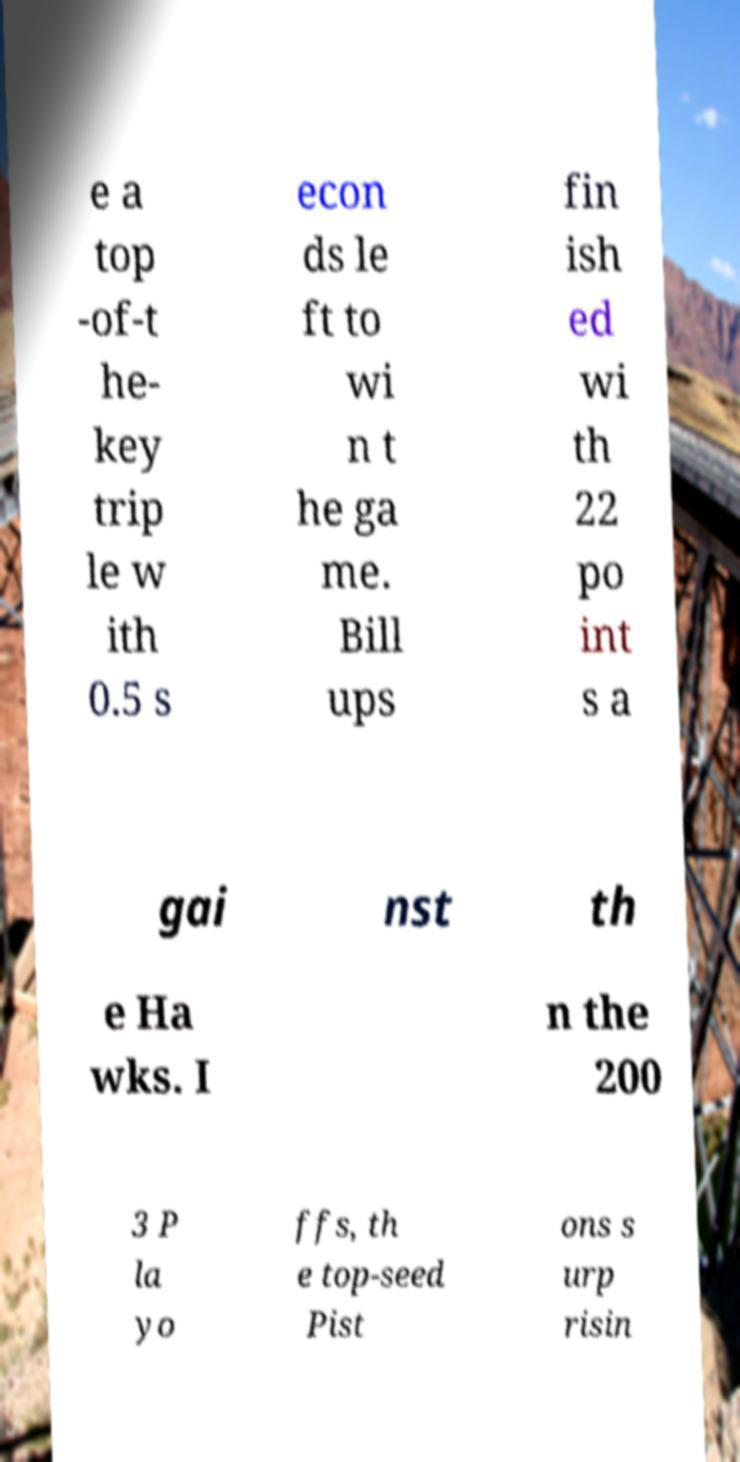Please identify and transcribe the text found in this image. e a top -of-t he- key trip le w ith 0.5 s econ ds le ft to wi n t he ga me. Bill ups fin ish ed wi th 22 po int s a gai nst th e Ha wks. I n the 200 3 P la yo ffs, th e top-seed Pist ons s urp risin 